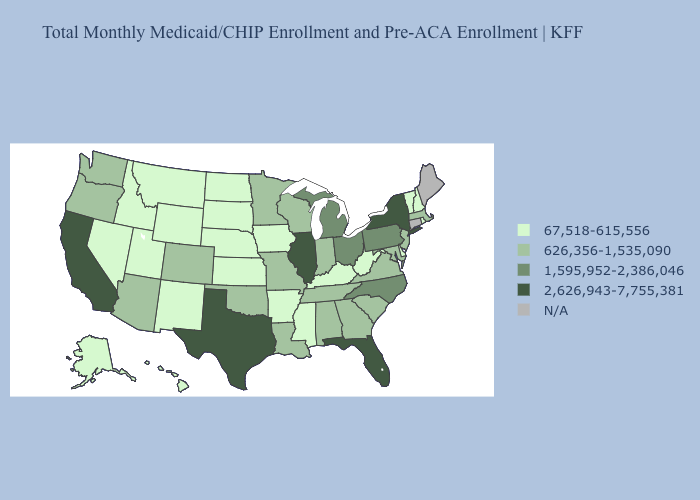What is the value of Minnesota?
Be succinct. 626,356-1,535,090. Among the states that border Delaware , does Pennsylvania have the lowest value?
Write a very short answer. No. Does Idaho have the lowest value in the USA?
Keep it brief. Yes. What is the value of New Hampshire?
Keep it brief. 67,518-615,556. Does Maryland have the lowest value in the South?
Concise answer only. No. Name the states that have a value in the range N/A?
Answer briefly. Connecticut, Maine. What is the value of Utah?
Answer briefly. 67,518-615,556. Which states have the lowest value in the USA?
Short answer required. Alaska, Arkansas, Delaware, Hawaii, Idaho, Iowa, Kansas, Kentucky, Mississippi, Montana, Nebraska, Nevada, New Hampshire, New Mexico, North Dakota, Rhode Island, South Dakota, Utah, Vermont, West Virginia, Wyoming. Name the states that have a value in the range 626,356-1,535,090?
Answer briefly. Alabama, Arizona, Colorado, Georgia, Indiana, Louisiana, Maryland, Massachusetts, Minnesota, Missouri, New Jersey, Oklahoma, Oregon, South Carolina, Tennessee, Virginia, Washington, Wisconsin. What is the lowest value in states that border Alabama?
Quick response, please. 67,518-615,556. Which states have the lowest value in the South?
Be succinct. Arkansas, Delaware, Kentucky, Mississippi, West Virginia. Is the legend a continuous bar?
Answer briefly. No. Does New York have the lowest value in the Northeast?
Quick response, please. No. How many symbols are there in the legend?
Quick response, please. 5. Name the states that have a value in the range N/A?
Keep it brief. Connecticut, Maine. 